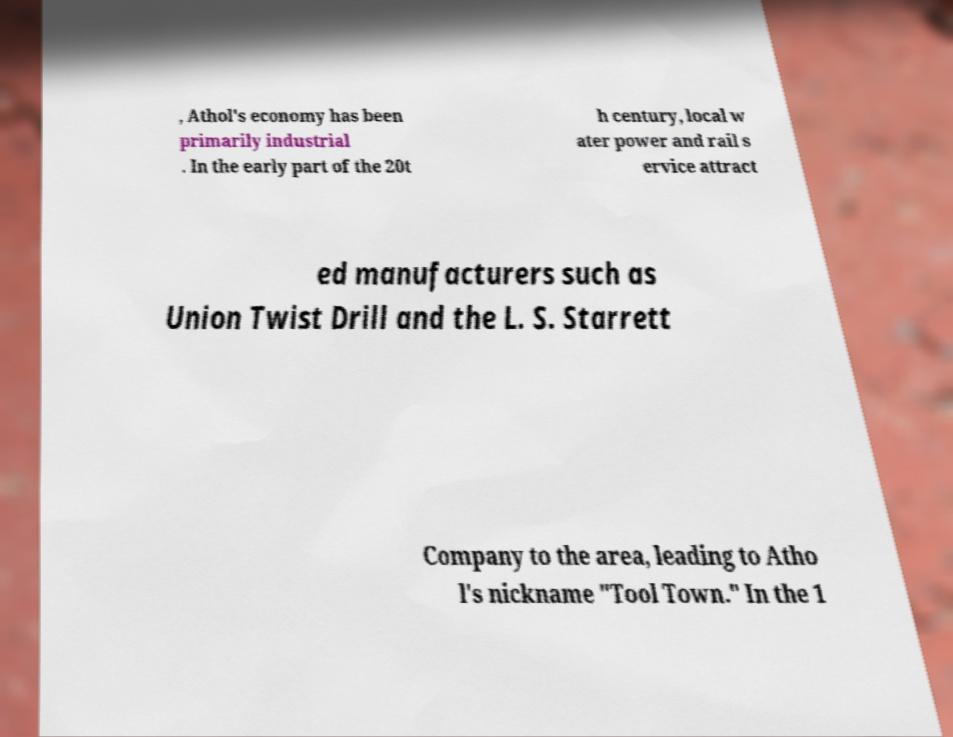Can you read and provide the text displayed in the image?This photo seems to have some interesting text. Can you extract and type it out for me? , Athol's economy has been primarily industrial . In the early part of the 20t h century, local w ater power and rail s ervice attract ed manufacturers such as Union Twist Drill and the L. S. Starrett Company to the area, leading to Atho l's nickname "Tool Town." In the 1 